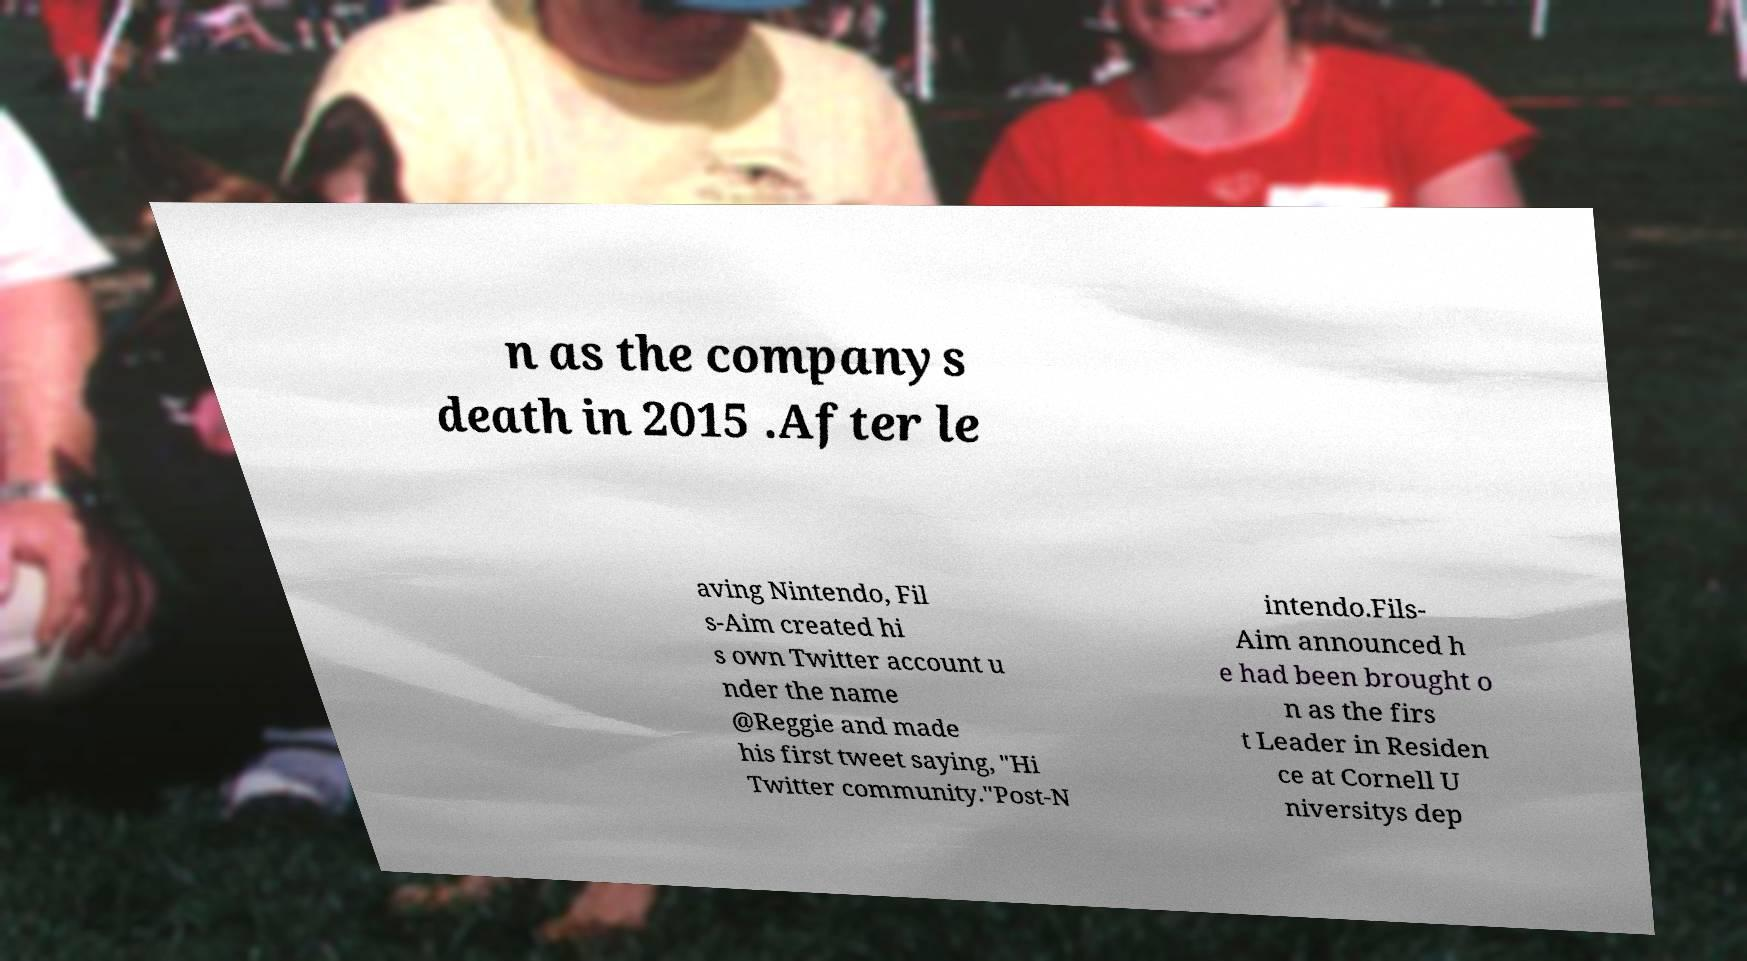Could you assist in decoding the text presented in this image and type it out clearly? n as the companys death in 2015 .After le aving Nintendo, Fil s-Aim created hi s own Twitter account u nder the name @Reggie and made his first tweet saying, "Hi Twitter community."Post-N intendo.Fils- Aim announced h e had been brought o n as the firs t Leader in Residen ce at Cornell U niversitys dep 